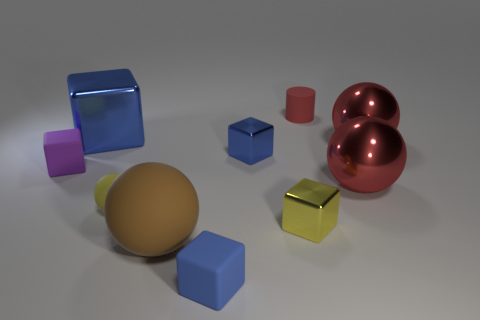How many brown matte things have the same size as the yellow matte ball?
Make the answer very short. 0. What shape is the yellow thing that is made of the same material as the small purple object?
Your answer should be very brief. Sphere. Are there any shiny balls of the same color as the small matte cylinder?
Keep it short and to the point. Yes. What material is the cylinder?
Offer a very short reply. Rubber. How many objects are small red cubes or large brown rubber balls?
Give a very brief answer. 1. How big is the matte object that is to the right of the yellow block?
Provide a succinct answer. Small. How many other things are the same material as the yellow sphere?
Ensure brevity in your answer.  4. There is a tiny blue cube in front of the small yellow shiny object; are there any tiny red cylinders left of it?
Your answer should be very brief. No. Are there any other things that are the same shape as the red rubber object?
Make the answer very short. No. What is the color of the large shiny object that is the same shape as the tiny blue rubber thing?
Your answer should be very brief. Blue. 